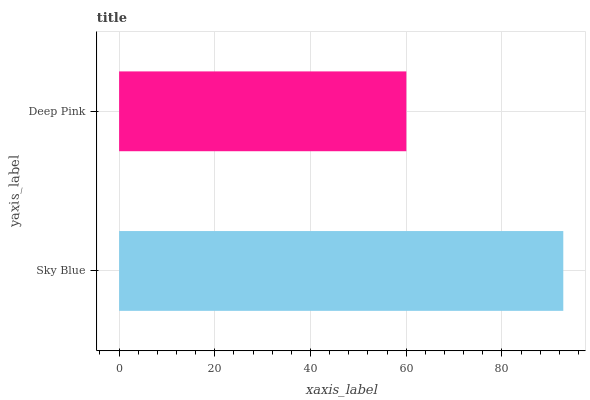Is Deep Pink the minimum?
Answer yes or no. Yes. Is Sky Blue the maximum?
Answer yes or no. Yes. Is Deep Pink the maximum?
Answer yes or no. No. Is Sky Blue greater than Deep Pink?
Answer yes or no. Yes. Is Deep Pink less than Sky Blue?
Answer yes or no. Yes. Is Deep Pink greater than Sky Blue?
Answer yes or no. No. Is Sky Blue less than Deep Pink?
Answer yes or no. No. Is Sky Blue the high median?
Answer yes or no. Yes. Is Deep Pink the low median?
Answer yes or no. Yes. Is Deep Pink the high median?
Answer yes or no. No. Is Sky Blue the low median?
Answer yes or no. No. 